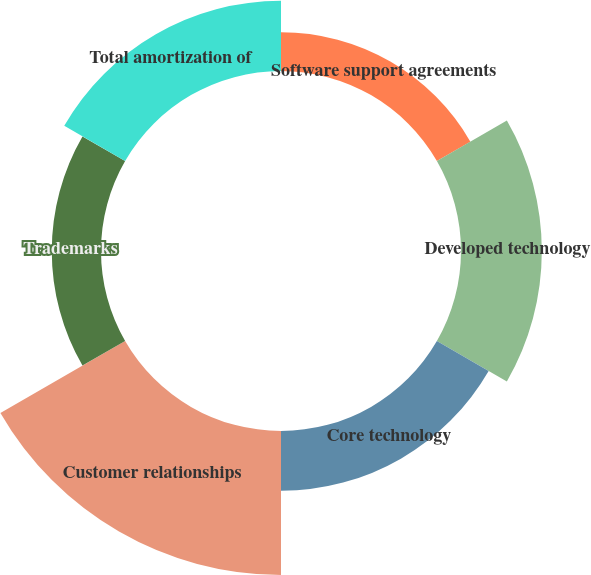Convert chart to OTSL. <chart><loc_0><loc_0><loc_500><loc_500><pie_chart><fcel>Software support agreements<fcel>Developed technology<fcel>Core technology<fcel>Customer relationships<fcel>Trademarks<fcel>Total amortization of<nl><fcel>8.74%<fcel>18.25%<fcel>13.5%<fcel>32.52%<fcel>11.12%<fcel>15.87%<nl></chart> 